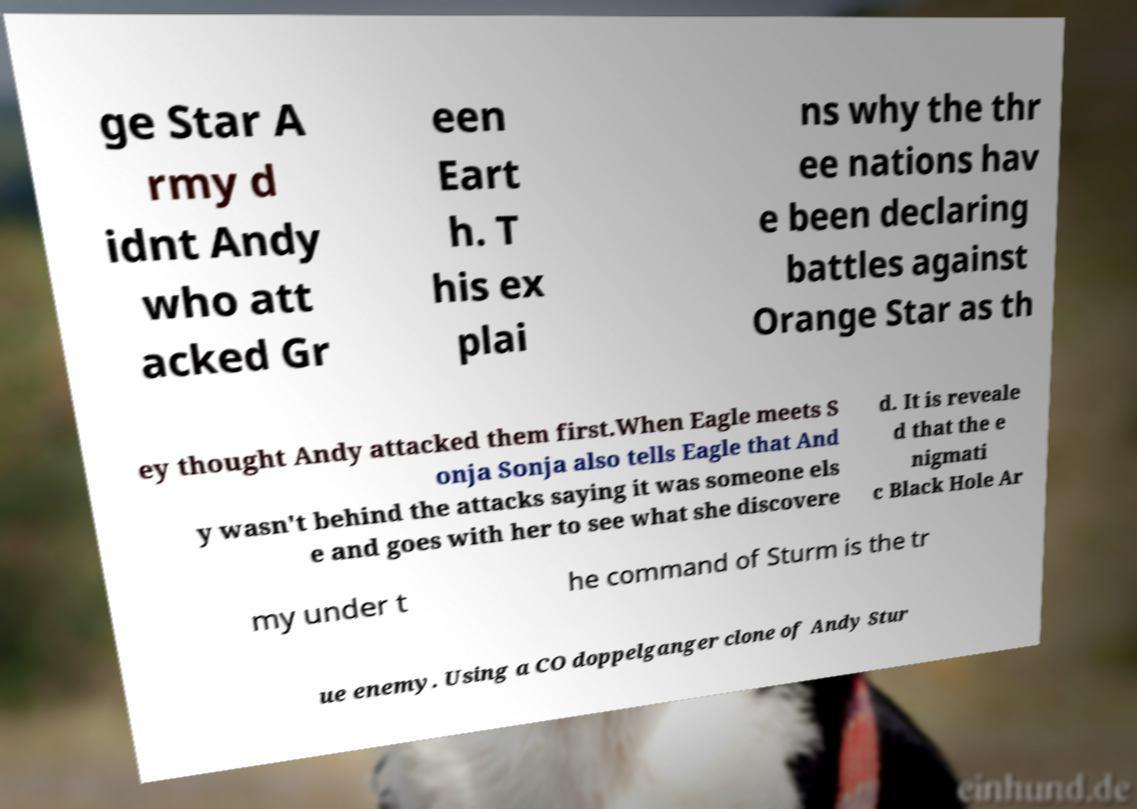I need the written content from this picture converted into text. Can you do that? ge Star A rmy d idnt Andy who att acked Gr een Eart h. T his ex plai ns why the thr ee nations hav e been declaring battles against Orange Star as th ey thought Andy attacked them first.When Eagle meets S onja Sonja also tells Eagle that And y wasn't behind the attacks saying it was someone els e and goes with her to see what she discovere d. It is reveale d that the e nigmati c Black Hole Ar my under t he command of Sturm is the tr ue enemy. Using a CO doppelganger clone of Andy Stur 